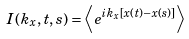<formula> <loc_0><loc_0><loc_500><loc_500>I ( k _ { x } , t , s ) = \left \langle e ^ { i k _ { x } \left [ x ( t ) - x ( s ) \right ] } \right \rangle</formula> 